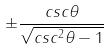Convert formula to latex. <formula><loc_0><loc_0><loc_500><loc_500>\pm \frac { c s c \theta } { \sqrt { c s c ^ { 2 } \theta - 1 } }</formula> 